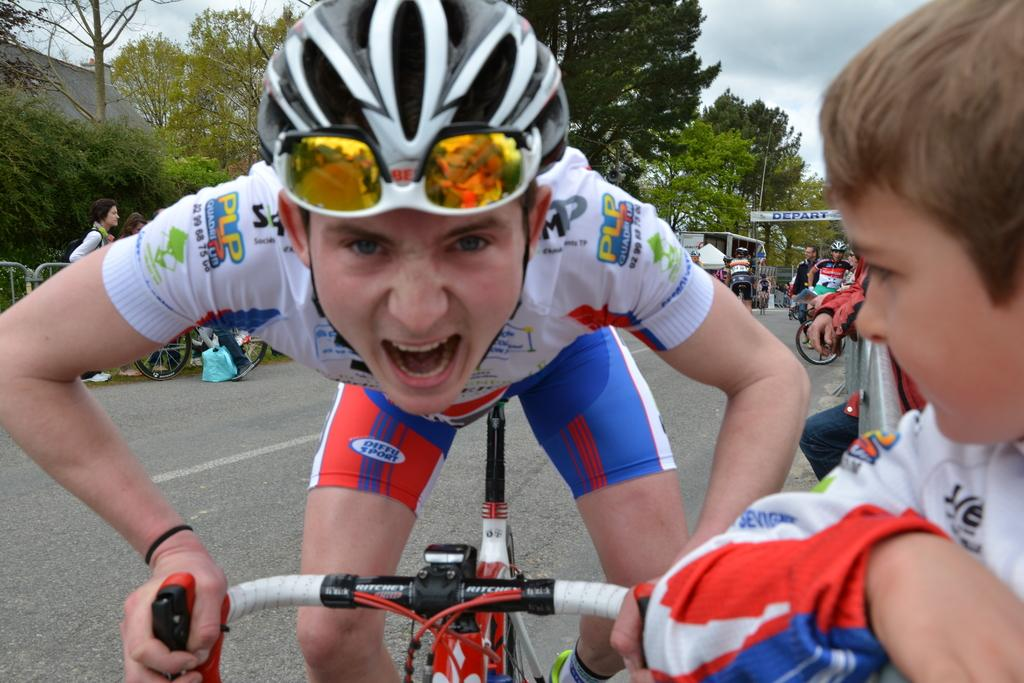Where was the image taken? The image is taken outdoors. What is the weather like in the image? It is sunny in the image. Can you describe the man in the image? There is a man in a white t-shirt in the image, and he is riding a bike. What surface is the man riding on? The man is on a road. What can be seen in the background of the image? There are trees and the sky visible in the background of the image. What appliance is the man using to drive the bike in the image? The man is not using any appliance to drive the bike in the image; he is pedaling it with his legs. Can you hear the man laughing in the image? There is no sound in the image, so it is not possible to hear the man laughing. 